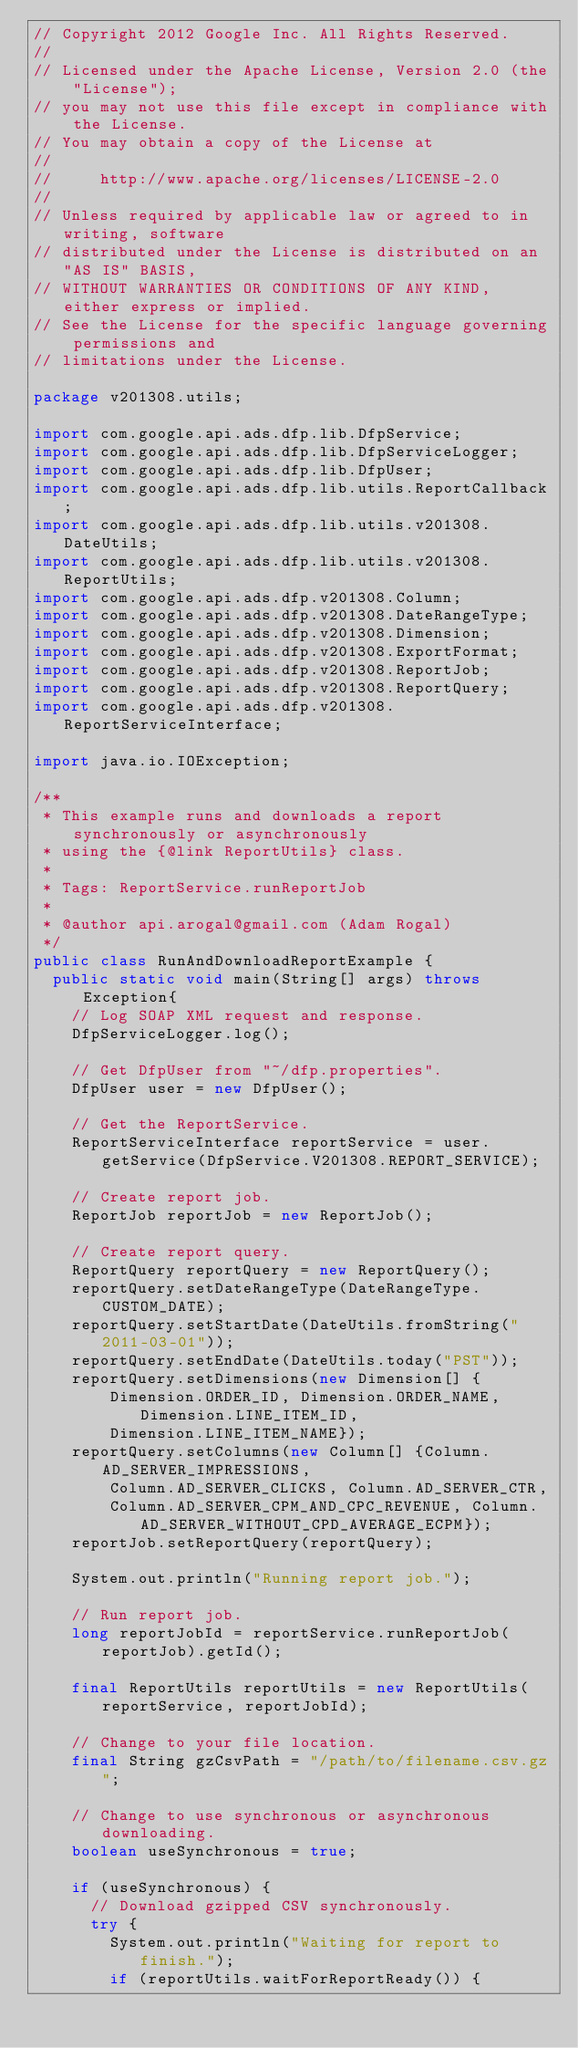Convert code to text. <code><loc_0><loc_0><loc_500><loc_500><_Java_>// Copyright 2012 Google Inc. All Rights Reserved.
//
// Licensed under the Apache License, Version 2.0 (the "License");
// you may not use this file except in compliance with the License.
// You may obtain a copy of the License at
//
//     http://www.apache.org/licenses/LICENSE-2.0
//
// Unless required by applicable law or agreed to in writing, software
// distributed under the License is distributed on an "AS IS" BASIS,
// WITHOUT WARRANTIES OR CONDITIONS OF ANY KIND, either express or implied.
// See the License for the specific language governing permissions and
// limitations under the License.

package v201308.utils;

import com.google.api.ads.dfp.lib.DfpService;
import com.google.api.ads.dfp.lib.DfpServiceLogger;
import com.google.api.ads.dfp.lib.DfpUser;
import com.google.api.ads.dfp.lib.utils.ReportCallback;
import com.google.api.ads.dfp.lib.utils.v201308.DateUtils;
import com.google.api.ads.dfp.lib.utils.v201308.ReportUtils;
import com.google.api.ads.dfp.v201308.Column;
import com.google.api.ads.dfp.v201308.DateRangeType;
import com.google.api.ads.dfp.v201308.Dimension;
import com.google.api.ads.dfp.v201308.ExportFormat;
import com.google.api.ads.dfp.v201308.ReportJob;
import com.google.api.ads.dfp.v201308.ReportQuery;
import com.google.api.ads.dfp.v201308.ReportServiceInterface;

import java.io.IOException;

/**
 * This example runs and downloads a report synchronously or asynchronously
 * using the {@link ReportUtils} class.
 *
 * Tags: ReportService.runReportJob
 *
 * @author api.arogal@gmail.com (Adam Rogal)
 */
public class RunAndDownloadReportExample {
  public static void main(String[] args) throws Exception{
    // Log SOAP XML request and response.
    DfpServiceLogger.log();

    // Get DfpUser from "~/dfp.properties".
    DfpUser user = new DfpUser();

    // Get the ReportService.
    ReportServiceInterface reportService = user.getService(DfpService.V201308.REPORT_SERVICE);

    // Create report job.
    ReportJob reportJob = new ReportJob();

    // Create report query.
    ReportQuery reportQuery = new ReportQuery();
    reportQuery.setDateRangeType(DateRangeType.CUSTOM_DATE);
    reportQuery.setStartDate(DateUtils.fromString("2011-03-01"));
    reportQuery.setEndDate(DateUtils.today("PST"));
    reportQuery.setDimensions(new Dimension[] {
        Dimension.ORDER_ID, Dimension.ORDER_NAME, Dimension.LINE_ITEM_ID,
        Dimension.LINE_ITEM_NAME});
    reportQuery.setColumns(new Column[] {Column.AD_SERVER_IMPRESSIONS,
        Column.AD_SERVER_CLICKS, Column.AD_SERVER_CTR,
        Column.AD_SERVER_CPM_AND_CPC_REVENUE, Column.AD_SERVER_WITHOUT_CPD_AVERAGE_ECPM});
    reportJob.setReportQuery(reportQuery);

    System.out.println("Running report job.");

    // Run report job.
    long reportJobId = reportService.runReportJob(reportJob).getId();

    final ReportUtils reportUtils = new ReportUtils(reportService, reportJobId);

    // Change to your file location.
    final String gzCsvPath = "/path/to/filename.csv.gz";

    // Change to use synchronous or asynchronous downloading.
    boolean useSynchronous = true;

    if (useSynchronous) {
      // Download gzipped CSV synchronously.
      try {
        System.out.println("Waiting for report to finish.");
        if (reportUtils.waitForReportReady()) {</code> 